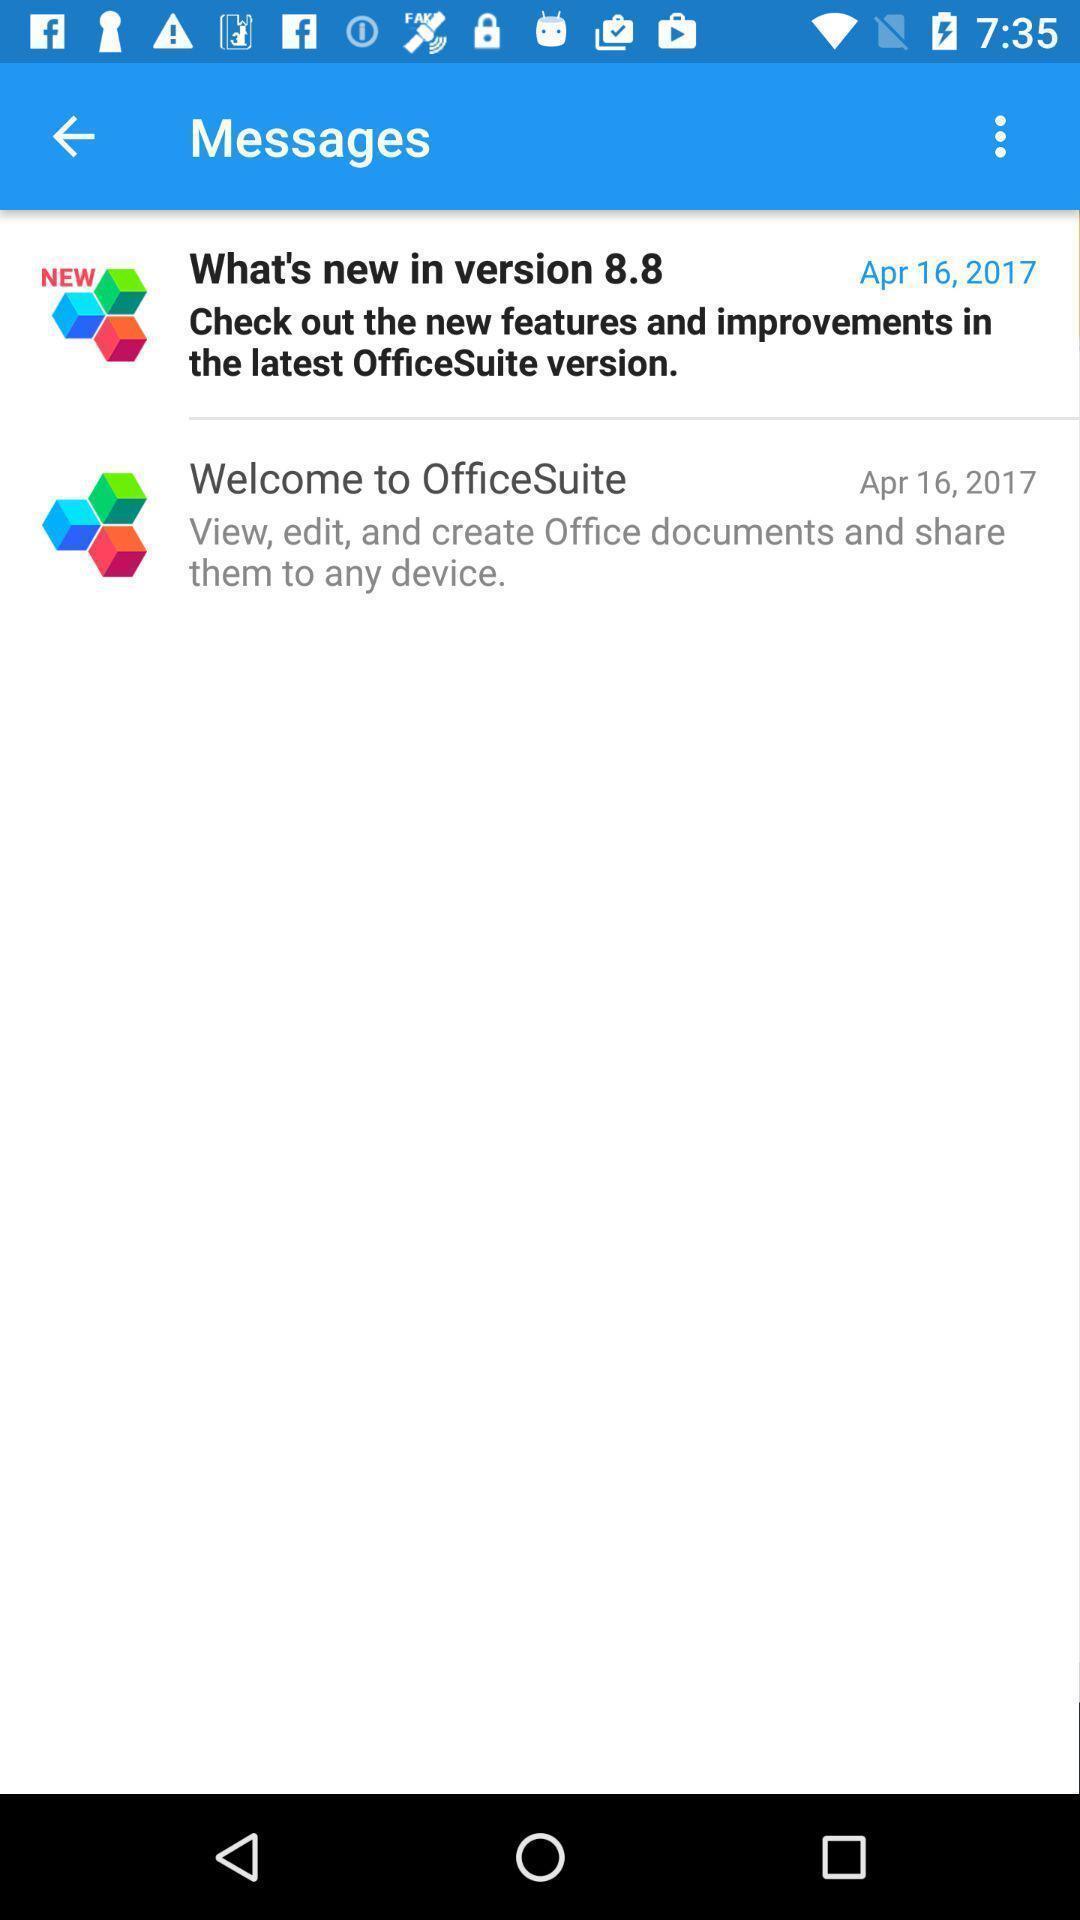Explain the elements present in this screenshot. Screen displaying the messages page. 